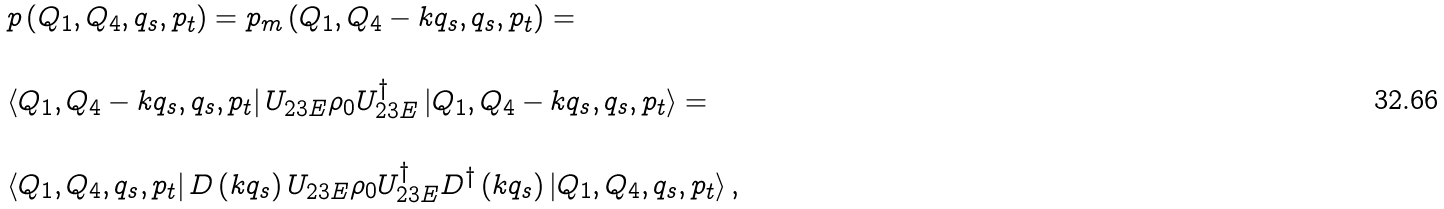<formula> <loc_0><loc_0><loc_500><loc_500>\begin{array} { l } p \left ( { { Q _ { 1 } } , { Q _ { 4 } } , { q _ { s } } , { p _ { t } } } \right ) = p _ { m } \left ( { { Q _ { 1 } } , { Q _ { 4 } } - k { q _ { s } } , { q _ { s } } , { p _ { t } } } \right ) = \\ \\ \left \langle { { Q _ { 1 } } , { Q _ { 4 } } - k { q _ { s } } , { q _ { s } } , { p _ { t } } } \right | { U _ { 2 3 E } } { \rho _ { 0 } } U _ { 2 3 E } ^ { \dag } \left | { { Q _ { 1 } } , { Q _ { 4 } } - k { q _ { s } } , { q _ { s } } , { p _ { t } } } \right \rangle = \\ \\ \left \langle { { Q _ { 1 } } , { Q _ { 4 } } , { q _ { s } } , { p _ { t } } } \right | D \left ( { k { q _ { s } } } \right ) { U _ { 2 3 E } } { \rho _ { 0 } } U _ { 2 3 E } ^ { \dag } { D ^ { \dag } } \left ( { k { q _ { s } } } \right ) \left | { { Q _ { 1 } } , { Q _ { 4 } } , { q _ { s } } , { p _ { t } } } \right \rangle , \end{array}</formula> 